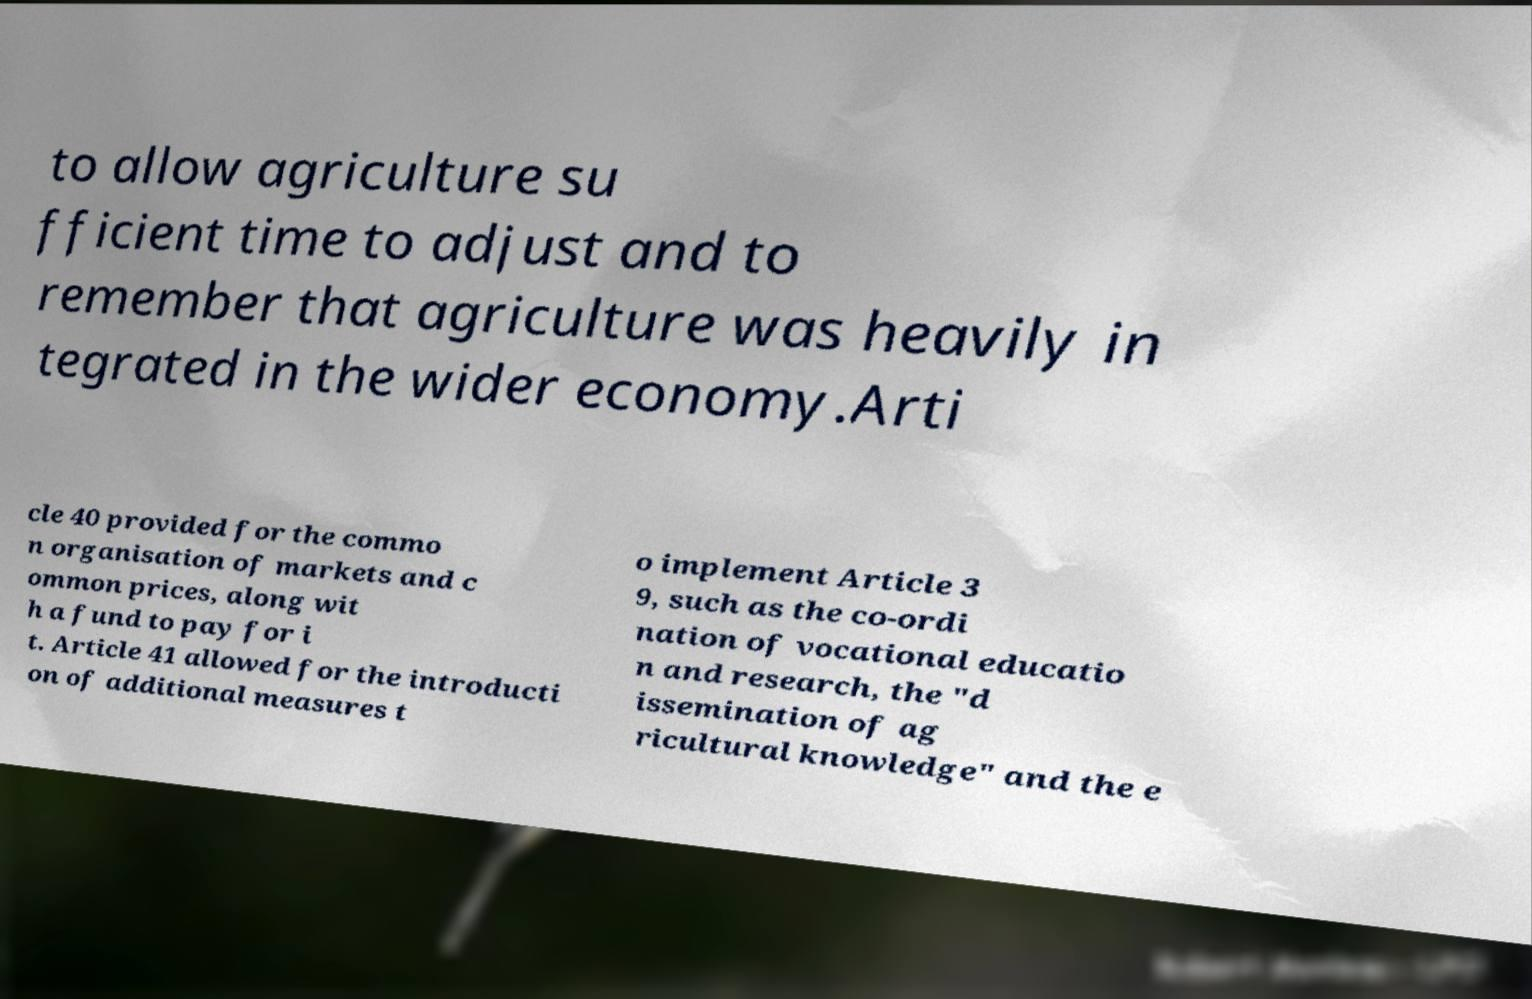I need the written content from this picture converted into text. Can you do that? to allow agriculture su fficient time to adjust and to remember that agriculture was heavily in tegrated in the wider economy.Arti cle 40 provided for the commo n organisation of markets and c ommon prices, along wit h a fund to pay for i t. Article 41 allowed for the introducti on of additional measures t o implement Article 3 9, such as the co-ordi nation of vocational educatio n and research, the "d issemination of ag ricultural knowledge" and the e 